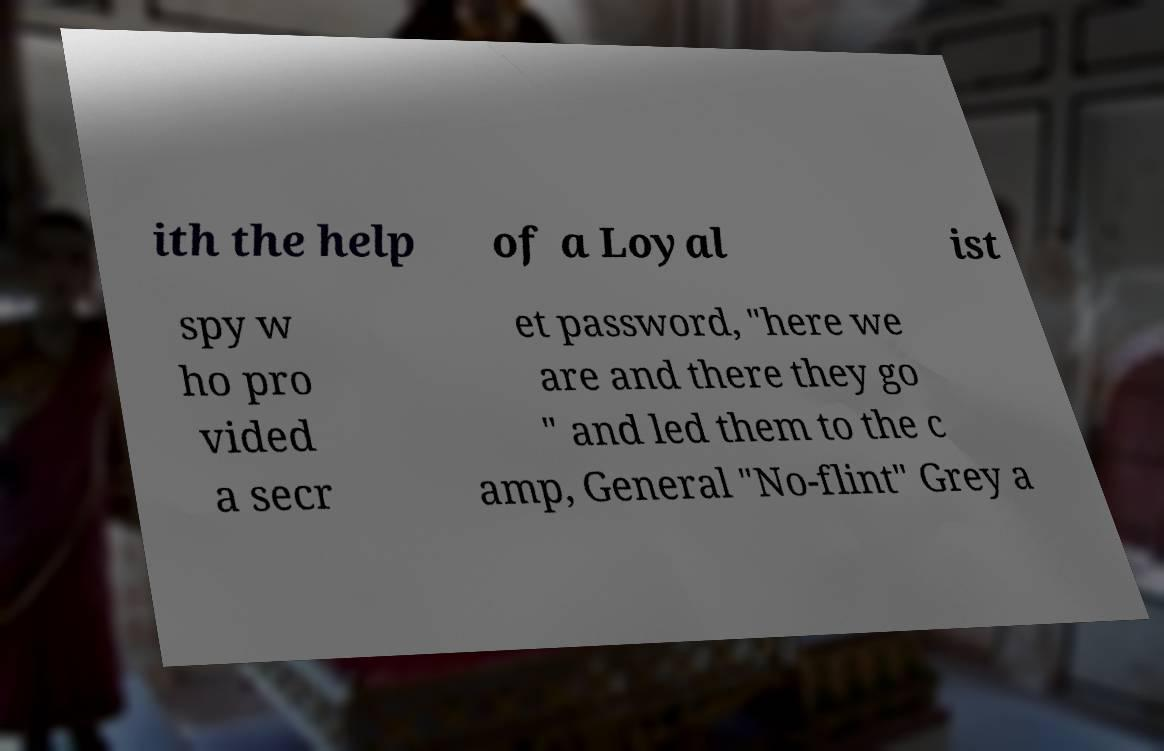There's text embedded in this image that I need extracted. Can you transcribe it verbatim? ith the help of a Loyal ist spy w ho pro vided a secr et password, "here we are and there they go " and led them to the c amp, General "No-flint" Grey a 